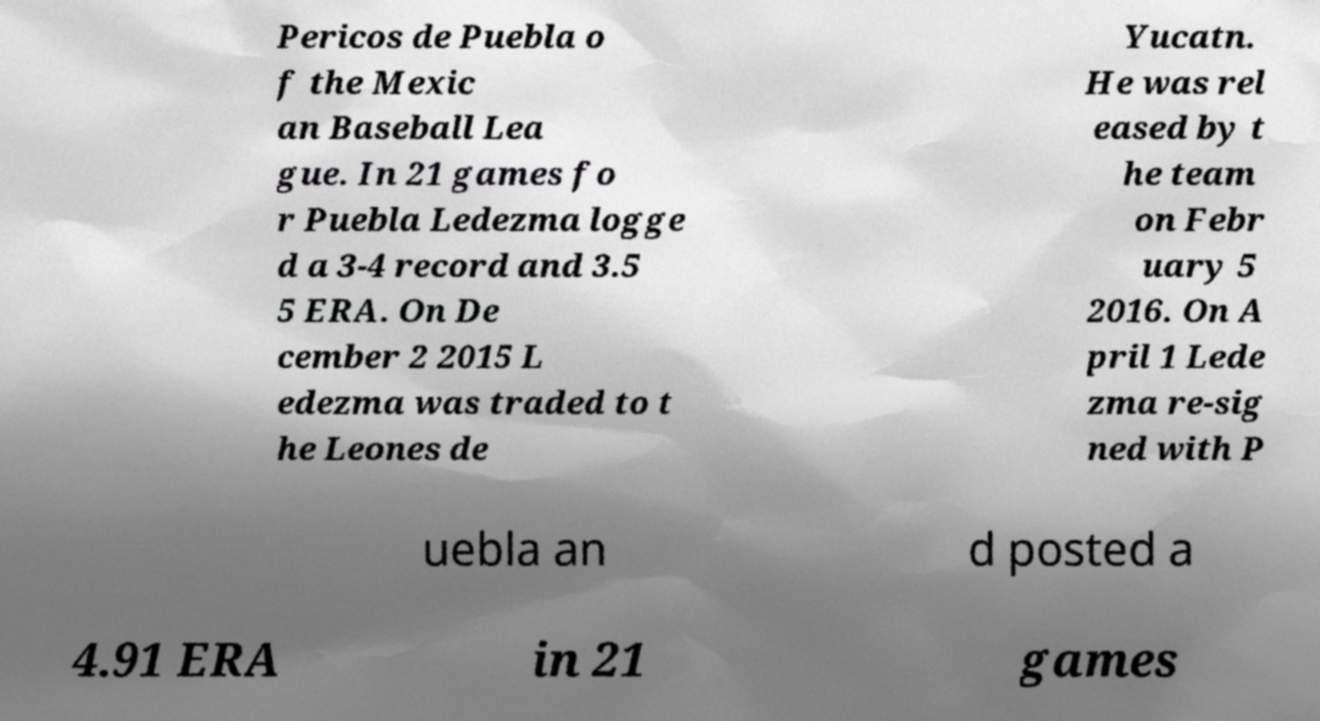Can you read and provide the text displayed in the image?This photo seems to have some interesting text. Can you extract and type it out for me? Pericos de Puebla o f the Mexic an Baseball Lea gue. In 21 games fo r Puebla Ledezma logge d a 3-4 record and 3.5 5 ERA. On De cember 2 2015 L edezma was traded to t he Leones de Yucatn. He was rel eased by t he team on Febr uary 5 2016. On A pril 1 Lede zma re-sig ned with P uebla an d posted a 4.91 ERA in 21 games 